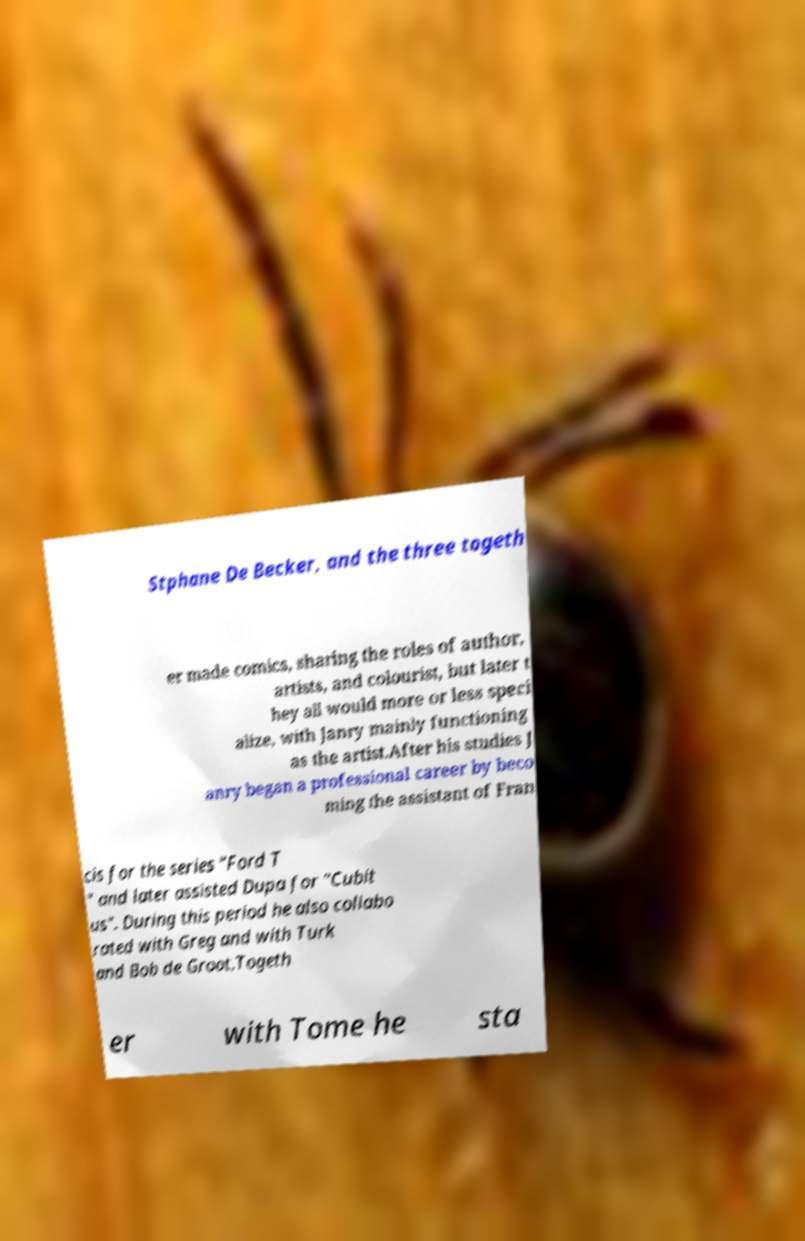Could you assist in decoding the text presented in this image and type it out clearly? Stphane De Becker, and the three togeth er made comics, sharing the roles of author, artists, and colourist, but later t hey all would more or less speci alize, with Janry mainly functioning as the artist.After his studies J anry began a professional career by beco ming the assistant of Fran cis for the series "Ford T " and later assisted Dupa for "Cubit us". During this period he also collabo rated with Greg and with Turk and Bob de Groot.Togeth er with Tome he sta 